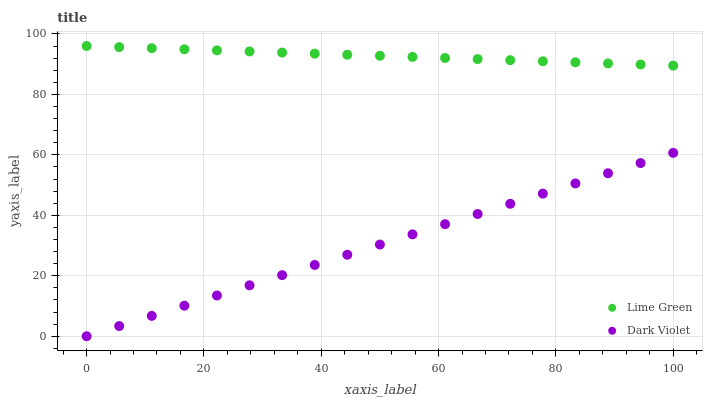Does Dark Violet have the minimum area under the curve?
Answer yes or no. Yes. Does Lime Green have the maximum area under the curve?
Answer yes or no. Yes. Does Dark Violet have the maximum area under the curve?
Answer yes or no. No. Is Dark Violet the smoothest?
Answer yes or no. Yes. Is Lime Green the roughest?
Answer yes or no. Yes. Is Dark Violet the roughest?
Answer yes or no. No. Does Dark Violet have the lowest value?
Answer yes or no. Yes. Does Lime Green have the highest value?
Answer yes or no. Yes. Does Dark Violet have the highest value?
Answer yes or no. No. Is Dark Violet less than Lime Green?
Answer yes or no. Yes. Is Lime Green greater than Dark Violet?
Answer yes or no. Yes. Does Dark Violet intersect Lime Green?
Answer yes or no. No. 